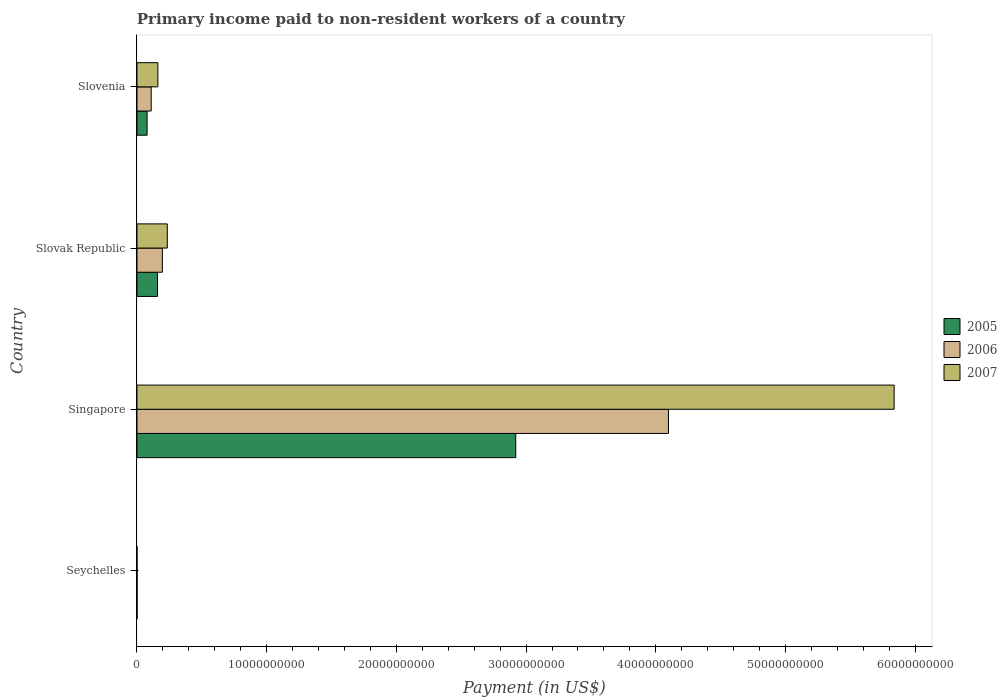What is the label of the 4th group of bars from the top?
Offer a terse response. Seychelles. What is the amount paid to workers in 2006 in Slovenia?
Provide a short and direct response. 1.10e+09. Across all countries, what is the maximum amount paid to workers in 2005?
Provide a short and direct response. 2.92e+1. Across all countries, what is the minimum amount paid to workers in 2007?
Offer a very short reply. 3.58e+06. In which country was the amount paid to workers in 2006 maximum?
Provide a short and direct response. Singapore. In which country was the amount paid to workers in 2005 minimum?
Your answer should be compact. Seychelles. What is the total amount paid to workers in 2005 in the graph?
Provide a succinct answer. 3.16e+1. What is the difference between the amount paid to workers in 2007 in Seychelles and that in Slovak Republic?
Provide a short and direct response. -2.34e+09. What is the difference between the amount paid to workers in 2005 in Slovenia and the amount paid to workers in 2007 in Seychelles?
Provide a succinct answer. 7.77e+08. What is the average amount paid to workers in 2005 per country?
Offer a very short reply. 7.89e+09. What is the difference between the amount paid to workers in 2006 and amount paid to workers in 2005 in Singapore?
Keep it short and to the point. 1.18e+1. What is the ratio of the amount paid to workers in 2005 in Singapore to that in Slovenia?
Give a very brief answer. 37.41. Is the difference between the amount paid to workers in 2006 in Seychelles and Slovenia greater than the difference between the amount paid to workers in 2005 in Seychelles and Slovenia?
Your answer should be compact. No. What is the difference between the highest and the second highest amount paid to workers in 2005?
Offer a very short reply. 2.76e+1. What is the difference between the highest and the lowest amount paid to workers in 2007?
Your answer should be compact. 5.84e+1. In how many countries, is the amount paid to workers in 2006 greater than the average amount paid to workers in 2006 taken over all countries?
Ensure brevity in your answer.  1. Is the sum of the amount paid to workers in 2006 in Slovak Republic and Slovenia greater than the maximum amount paid to workers in 2005 across all countries?
Give a very brief answer. No. Is it the case that in every country, the sum of the amount paid to workers in 2006 and amount paid to workers in 2005 is greater than the amount paid to workers in 2007?
Offer a terse response. Yes. How many bars are there?
Your answer should be compact. 12. Are all the bars in the graph horizontal?
Your answer should be very brief. Yes. Does the graph contain any zero values?
Offer a terse response. No. Where does the legend appear in the graph?
Keep it short and to the point. Center right. What is the title of the graph?
Your answer should be compact. Primary income paid to non-resident workers of a country. Does "1983" appear as one of the legend labels in the graph?
Provide a short and direct response. No. What is the label or title of the X-axis?
Provide a short and direct response. Payment (in US$). What is the label or title of the Y-axis?
Offer a very short reply. Country. What is the Payment (in US$) in 2005 in Seychelles?
Your answer should be compact. 9.81e+06. What is the Payment (in US$) in 2006 in Seychelles?
Your answer should be very brief. 1.03e+07. What is the Payment (in US$) in 2007 in Seychelles?
Offer a very short reply. 3.58e+06. What is the Payment (in US$) of 2005 in Singapore?
Offer a very short reply. 2.92e+1. What is the Payment (in US$) in 2006 in Singapore?
Give a very brief answer. 4.10e+1. What is the Payment (in US$) in 2007 in Singapore?
Your response must be concise. 5.84e+1. What is the Payment (in US$) in 2005 in Slovak Republic?
Offer a terse response. 1.58e+09. What is the Payment (in US$) in 2006 in Slovak Republic?
Offer a terse response. 1.96e+09. What is the Payment (in US$) of 2007 in Slovak Republic?
Offer a terse response. 2.34e+09. What is the Payment (in US$) in 2005 in Slovenia?
Keep it short and to the point. 7.81e+08. What is the Payment (in US$) in 2006 in Slovenia?
Make the answer very short. 1.10e+09. What is the Payment (in US$) of 2007 in Slovenia?
Provide a succinct answer. 1.61e+09. Across all countries, what is the maximum Payment (in US$) of 2005?
Your answer should be very brief. 2.92e+1. Across all countries, what is the maximum Payment (in US$) of 2006?
Give a very brief answer. 4.10e+1. Across all countries, what is the maximum Payment (in US$) of 2007?
Your answer should be very brief. 5.84e+1. Across all countries, what is the minimum Payment (in US$) of 2005?
Provide a short and direct response. 9.81e+06. Across all countries, what is the minimum Payment (in US$) in 2006?
Provide a short and direct response. 1.03e+07. Across all countries, what is the minimum Payment (in US$) in 2007?
Keep it short and to the point. 3.58e+06. What is the total Payment (in US$) of 2005 in the graph?
Give a very brief answer. 3.16e+1. What is the total Payment (in US$) of 2006 in the graph?
Make the answer very short. 4.40e+1. What is the total Payment (in US$) in 2007 in the graph?
Provide a succinct answer. 6.23e+1. What is the difference between the Payment (in US$) in 2005 in Seychelles and that in Singapore?
Make the answer very short. -2.92e+1. What is the difference between the Payment (in US$) of 2006 in Seychelles and that in Singapore?
Offer a very short reply. -4.10e+1. What is the difference between the Payment (in US$) in 2007 in Seychelles and that in Singapore?
Ensure brevity in your answer.  -5.84e+1. What is the difference between the Payment (in US$) in 2005 in Seychelles and that in Slovak Republic?
Give a very brief answer. -1.58e+09. What is the difference between the Payment (in US$) of 2006 in Seychelles and that in Slovak Republic?
Your response must be concise. -1.95e+09. What is the difference between the Payment (in US$) of 2007 in Seychelles and that in Slovak Republic?
Keep it short and to the point. -2.34e+09. What is the difference between the Payment (in US$) of 2005 in Seychelles and that in Slovenia?
Keep it short and to the point. -7.71e+08. What is the difference between the Payment (in US$) of 2006 in Seychelles and that in Slovenia?
Your answer should be very brief. -1.09e+09. What is the difference between the Payment (in US$) of 2007 in Seychelles and that in Slovenia?
Ensure brevity in your answer.  -1.61e+09. What is the difference between the Payment (in US$) in 2005 in Singapore and that in Slovak Republic?
Ensure brevity in your answer.  2.76e+1. What is the difference between the Payment (in US$) of 2006 in Singapore and that in Slovak Republic?
Provide a succinct answer. 3.90e+1. What is the difference between the Payment (in US$) of 2007 in Singapore and that in Slovak Republic?
Offer a terse response. 5.60e+1. What is the difference between the Payment (in US$) in 2005 in Singapore and that in Slovenia?
Ensure brevity in your answer.  2.84e+1. What is the difference between the Payment (in US$) in 2006 in Singapore and that in Slovenia?
Ensure brevity in your answer.  3.99e+1. What is the difference between the Payment (in US$) of 2007 in Singapore and that in Slovenia?
Offer a very short reply. 5.68e+1. What is the difference between the Payment (in US$) of 2005 in Slovak Republic and that in Slovenia?
Your answer should be compact. 8.04e+08. What is the difference between the Payment (in US$) of 2006 in Slovak Republic and that in Slovenia?
Your answer should be very brief. 8.62e+08. What is the difference between the Payment (in US$) of 2007 in Slovak Republic and that in Slovenia?
Provide a short and direct response. 7.30e+08. What is the difference between the Payment (in US$) of 2005 in Seychelles and the Payment (in US$) of 2006 in Singapore?
Give a very brief answer. -4.10e+1. What is the difference between the Payment (in US$) of 2005 in Seychelles and the Payment (in US$) of 2007 in Singapore?
Your answer should be compact. -5.84e+1. What is the difference between the Payment (in US$) of 2006 in Seychelles and the Payment (in US$) of 2007 in Singapore?
Your response must be concise. -5.84e+1. What is the difference between the Payment (in US$) of 2005 in Seychelles and the Payment (in US$) of 2006 in Slovak Republic?
Your response must be concise. -1.95e+09. What is the difference between the Payment (in US$) of 2005 in Seychelles and the Payment (in US$) of 2007 in Slovak Republic?
Give a very brief answer. -2.33e+09. What is the difference between the Payment (in US$) in 2006 in Seychelles and the Payment (in US$) in 2007 in Slovak Republic?
Your answer should be compact. -2.33e+09. What is the difference between the Payment (in US$) in 2005 in Seychelles and the Payment (in US$) in 2006 in Slovenia?
Give a very brief answer. -1.09e+09. What is the difference between the Payment (in US$) in 2005 in Seychelles and the Payment (in US$) in 2007 in Slovenia?
Make the answer very short. -1.60e+09. What is the difference between the Payment (in US$) of 2006 in Seychelles and the Payment (in US$) of 2007 in Slovenia?
Offer a terse response. -1.60e+09. What is the difference between the Payment (in US$) in 2005 in Singapore and the Payment (in US$) in 2006 in Slovak Republic?
Offer a terse response. 2.72e+1. What is the difference between the Payment (in US$) of 2005 in Singapore and the Payment (in US$) of 2007 in Slovak Republic?
Your response must be concise. 2.69e+1. What is the difference between the Payment (in US$) in 2006 in Singapore and the Payment (in US$) in 2007 in Slovak Republic?
Offer a terse response. 3.86e+1. What is the difference between the Payment (in US$) in 2005 in Singapore and the Payment (in US$) in 2006 in Slovenia?
Offer a very short reply. 2.81e+1. What is the difference between the Payment (in US$) of 2005 in Singapore and the Payment (in US$) of 2007 in Slovenia?
Ensure brevity in your answer.  2.76e+1. What is the difference between the Payment (in US$) of 2006 in Singapore and the Payment (in US$) of 2007 in Slovenia?
Offer a very short reply. 3.94e+1. What is the difference between the Payment (in US$) of 2005 in Slovak Republic and the Payment (in US$) of 2006 in Slovenia?
Offer a very short reply. 4.88e+08. What is the difference between the Payment (in US$) in 2005 in Slovak Republic and the Payment (in US$) in 2007 in Slovenia?
Keep it short and to the point. -2.44e+07. What is the difference between the Payment (in US$) in 2006 in Slovak Republic and the Payment (in US$) in 2007 in Slovenia?
Provide a short and direct response. 3.50e+08. What is the average Payment (in US$) of 2005 per country?
Your response must be concise. 7.89e+09. What is the average Payment (in US$) of 2006 per country?
Make the answer very short. 1.10e+1. What is the average Payment (in US$) in 2007 per country?
Give a very brief answer. 1.56e+1. What is the difference between the Payment (in US$) of 2005 and Payment (in US$) of 2006 in Seychelles?
Provide a succinct answer. -4.60e+05. What is the difference between the Payment (in US$) of 2005 and Payment (in US$) of 2007 in Seychelles?
Keep it short and to the point. 6.23e+06. What is the difference between the Payment (in US$) of 2006 and Payment (in US$) of 2007 in Seychelles?
Ensure brevity in your answer.  6.69e+06. What is the difference between the Payment (in US$) of 2005 and Payment (in US$) of 2006 in Singapore?
Provide a succinct answer. -1.18e+1. What is the difference between the Payment (in US$) of 2005 and Payment (in US$) of 2007 in Singapore?
Offer a terse response. -2.92e+1. What is the difference between the Payment (in US$) in 2006 and Payment (in US$) in 2007 in Singapore?
Provide a short and direct response. -1.74e+1. What is the difference between the Payment (in US$) in 2005 and Payment (in US$) in 2006 in Slovak Republic?
Offer a very short reply. -3.74e+08. What is the difference between the Payment (in US$) in 2005 and Payment (in US$) in 2007 in Slovak Republic?
Ensure brevity in your answer.  -7.55e+08. What is the difference between the Payment (in US$) in 2006 and Payment (in US$) in 2007 in Slovak Republic?
Your answer should be very brief. -3.81e+08. What is the difference between the Payment (in US$) of 2005 and Payment (in US$) of 2006 in Slovenia?
Provide a short and direct response. -3.17e+08. What is the difference between the Payment (in US$) of 2005 and Payment (in US$) of 2007 in Slovenia?
Make the answer very short. -8.29e+08. What is the difference between the Payment (in US$) of 2006 and Payment (in US$) of 2007 in Slovenia?
Your answer should be very brief. -5.12e+08. What is the ratio of the Payment (in US$) of 2006 in Seychelles to that in Singapore?
Give a very brief answer. 0. What is the ratio of the Payment (in US$) in 2005 in Seychelles to that in Slovak Republic?
Your response must be concise. 0.01. What is the ratio of the Payment (in US$) of 2006 in Seychelles to that in Slovak Republic?
Your answer should be very brief. 0.01. What is the ratio of the Payment (in US$) of 2007 in Seychelles to that in Slovak Republic?
Your answer should be compact. 0. What is the ratio of the Payment (in US$) of 2005 in Seychelles to that in Slovenia?
Offer a terse response. 0.01. What is the ratio of the Payment (in US$) of 2006 in Seychelles to that in Slovenia?
Make the answer very short. 0.01. What is the ratio of the Payment (in US$) of 2007 in Seychelles to that in Slovenia?
Your answer should be very brief. 0. What is the ratio of the Payment (in US$) in 2005 in Singapore to that in Slovak Republic?
Your response must be concise. 18.42. What is the ratio of the Payment (in US$) in 2006 in Singapore to that in Slovak Republic?
Give a very brief answer. 20.92. What is the ratio of the Payment (in US$) of 2007 in Singapore to that in Slovak Republic?
Your answer should be compact. 24.95. What is the ratio of the Payment (in US$) of 2005 in Singapore to that in Slovenia?
Offer a terse response. 37.41. What is the ratio of the Payment (in US$) of 2006 in Singapore to that in Slovenia?
Your answer should be compact. 37.34. What is the ratio of the Payment (in US$) of 2007 in Singapore to that in Slovenia?
Make the answer very short. 36.27. What is the ratio of the Payment (in US$) in 2005 in Slovak Republic to that in Slovenia?
Ensure brevity in your answer.  2.03. What is the ratio of the Payment (in US$) of 2006 in Slovak Republic to that in Slovenia?
Keep it short and to the point. 1.79. What is the ratio of the Payment (in US$) of 2007 in Slovak Republic to that in Slovenia?
Your response must be concise. 1.45. What is the difference between the highest and the second highest Payment (in US$) of 2005?
Offer a very short reply. 2.76e+1. What is the difference between the highest and the second highest Payment (in US$) of 2006?
Provide a short and direct response. 3.90e+1. What is the difference between the highest and the second highest Payment (in US$) of 2007?
Provide a succinct answer. 5.60e+1. What is the difference between the highest and the lowest Payment (in US$) in 2005?
Make the answer very short. 2.92e+1. What is the difference between the highest and the lowest Payment (in US$) of 2006?
Your answer should be compact. 4.10e+1. What is the difference between the highest and the lowest Payment (in US$) of 2007?
Your answer should be very brief. 5.84e+1. 